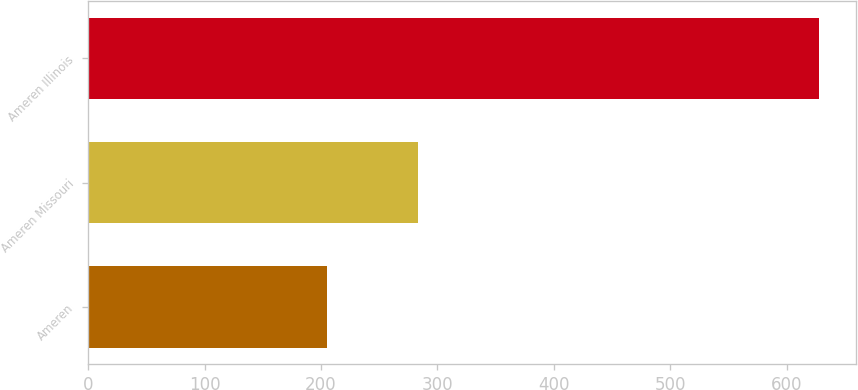<chart> <loc_0><loc_0><loc_500><loc_500><bar_chart><fcel>Ameren<fcel>Ameren Missouri<fcel>Ameren Illinois<nl><fcel>205<fcel>283<fcel>628<nl></chart> 